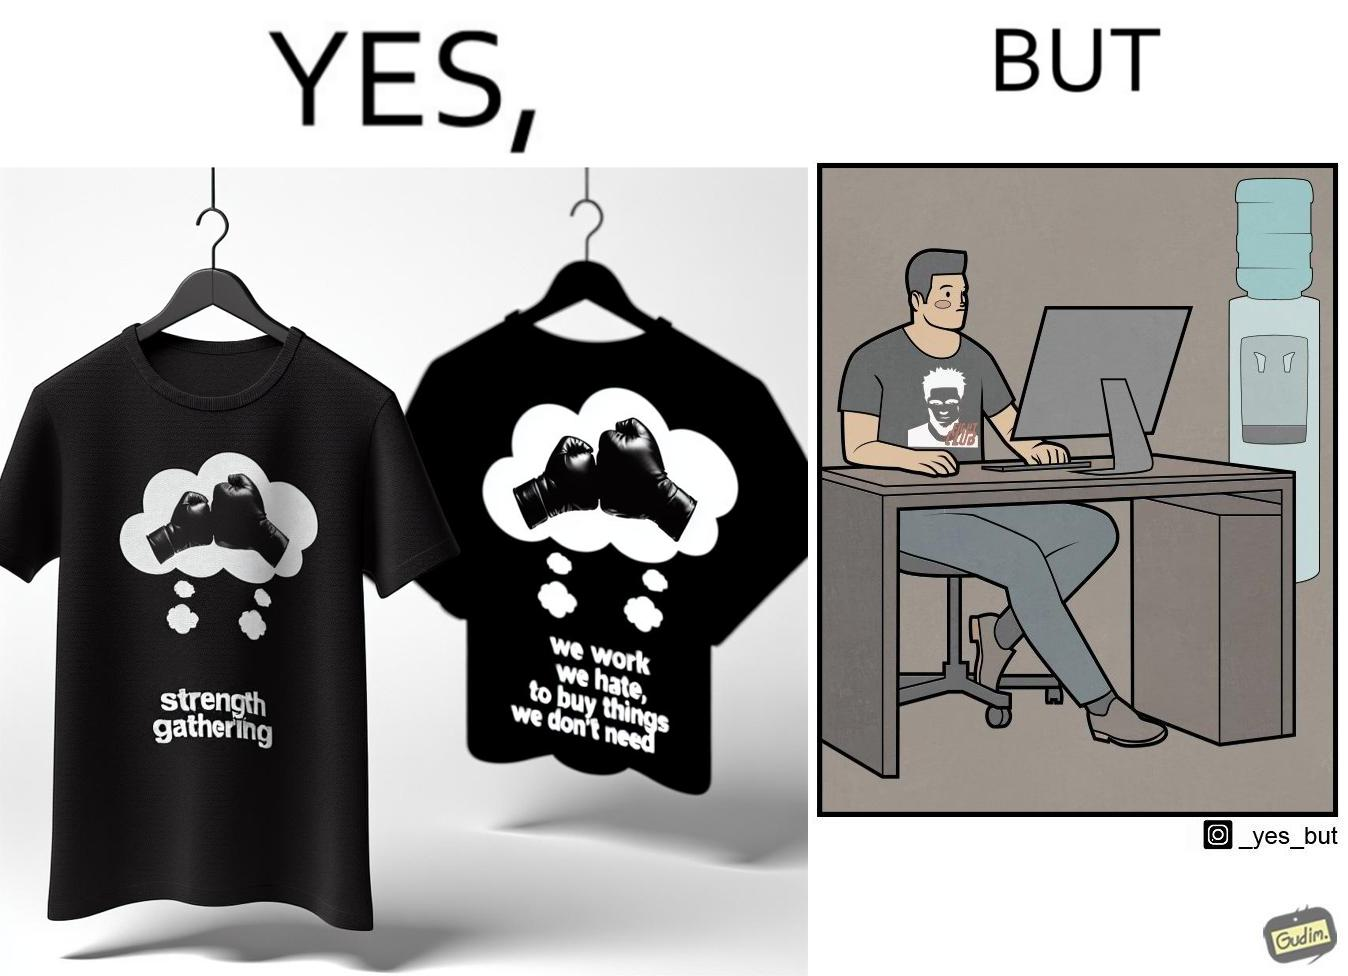Is this a satirical image? Yes, this image is satirical. 